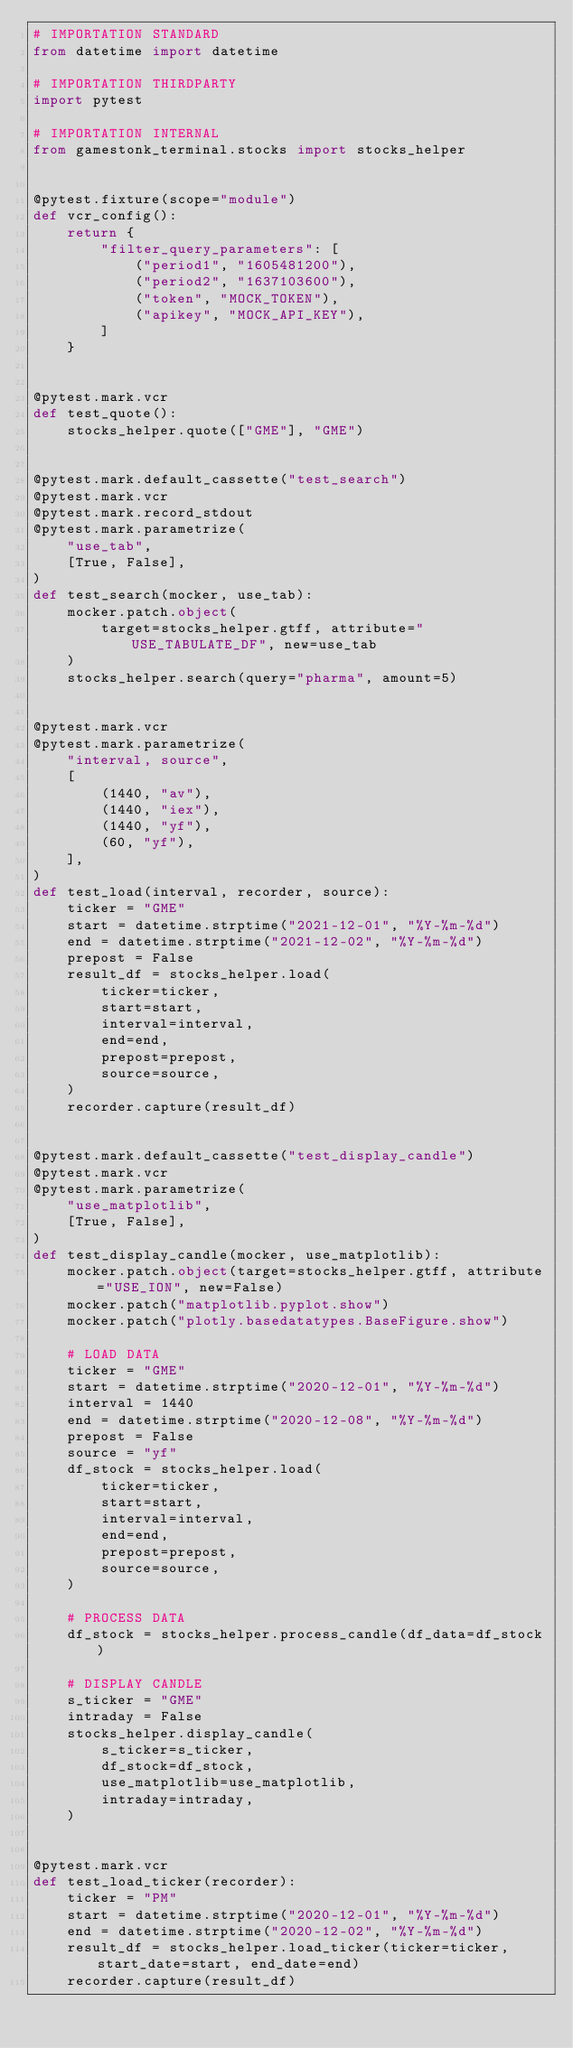<code> <loc_0><loc_0><loc_500><loc_500><_Python_># IMPORTATION STANDARD
from datetime import datetime

# IMPORTATION THIRDPARTY
import pytest

# IMPORTATION INTERNAL
from gamestonk_terminal.stocks import stocks_helper


@pytest.fixture(scope="module")
def vcr_config():
    return {
        "filter_query_parameters": [
            ("period1", "1605481200"),
            ("period2", "1637103600"),
            ("token", "MOCK_TOKEN"),
            ("apikey", "MOCK_API_KEY"),
        ]
    }


@pytest.mark.vcr
def test_quote():
    stocks_helper.quote(["GME"], "GME")


@pytest.mark.default_cassette("test_search")
@pytest.mark.vcr
@pytest.mark.record_stdout
@pytest.mark.parametrize(
    "use_tab",
    [True, False],
)
def test_search(mocker, use_tab):
    mocker.patch.object(
        target=stocks_helper.gtff, attribute="USE_TABULATE_DF", new=use_tab
    )
    stocks_helper.search(query="pharma", amount=5)


@pytest.mark.vcr
@pytest.mark.parametrize(
    "interval, source",
    [
        (1440, "av"),
        (1440, "iex"),
        (1440, "yf"),
        (60, "yf"),
    ],
)
def test_load(interval, recorder, source):
    ticker = "GME"
    start = datetime.strptime("2021-12-01", "%Y-%m-%d")
    end = datetime.strptime("2021-12-02", "%Y-%m-%d")
    prepost = False
    result_df = stocks_helper.load(
        ticker=ticker,
        start=start,
        interval=interval,
        end=end,
        prepost=prepost,
        source=source,
    )
    recorder.capture(result_df)


@pytest.mark.default_cassette("test_display_candle")
@pytest.mark.vcr
@pytest.mark.parametrize(
    "use_matplotlib",
    [True, False],
)
def test_display_candle(mocker, use_matplotlib):
    mocker.patch.object(target=stocks_helper.gtff, attribute="USE_ION", new=False)
    mocker.patch("matplotlib.pyplot.show")
    mocker.patch("plotly.basedatatypes.BaseFigure.show")

    # LOAD DATA
    ticker = "GME"
    start = datetime.strptime("2020-12-01", "%Y-%m-%d")
    interval = 1440
    end = datetime.strptime("2020-12-08", "%Y-%m-%d")
    prepost = False
    source = "yf"
    df_stock = stocks_helper.load(
        ticker=ticker,
        start=start,
        interval=interval,
        end=end,
        prepost=prepost,
        source=source,
    )

    # PROCESS DATA
    df_stock = stocks_helper.process_candle(df_data=df_stock)

    # DISPLAY CANDLE
    s_ticker = "GME"
    intraday = False
    stocks_helper.display_candle(
        s_ticker=s_ticker,
        df_stock=df_stock,
        use_matplotlib=use_matplotlib,
        intraday=intraday,
    )


@pytest.mark.vcr
def test_load_ticker(recorder):
    ticker = "PM"
    start = datetime.strptime("2020-12-01", "%Y-%m-%d")
    end = datetime.strptime("2020-12-02", "%Y-%m-%d")
    result_df = stocks_helper.load_ticker(ticker=ticker, start_date=start, end_date=end)
    recorder.capture(result_df)
</code> 